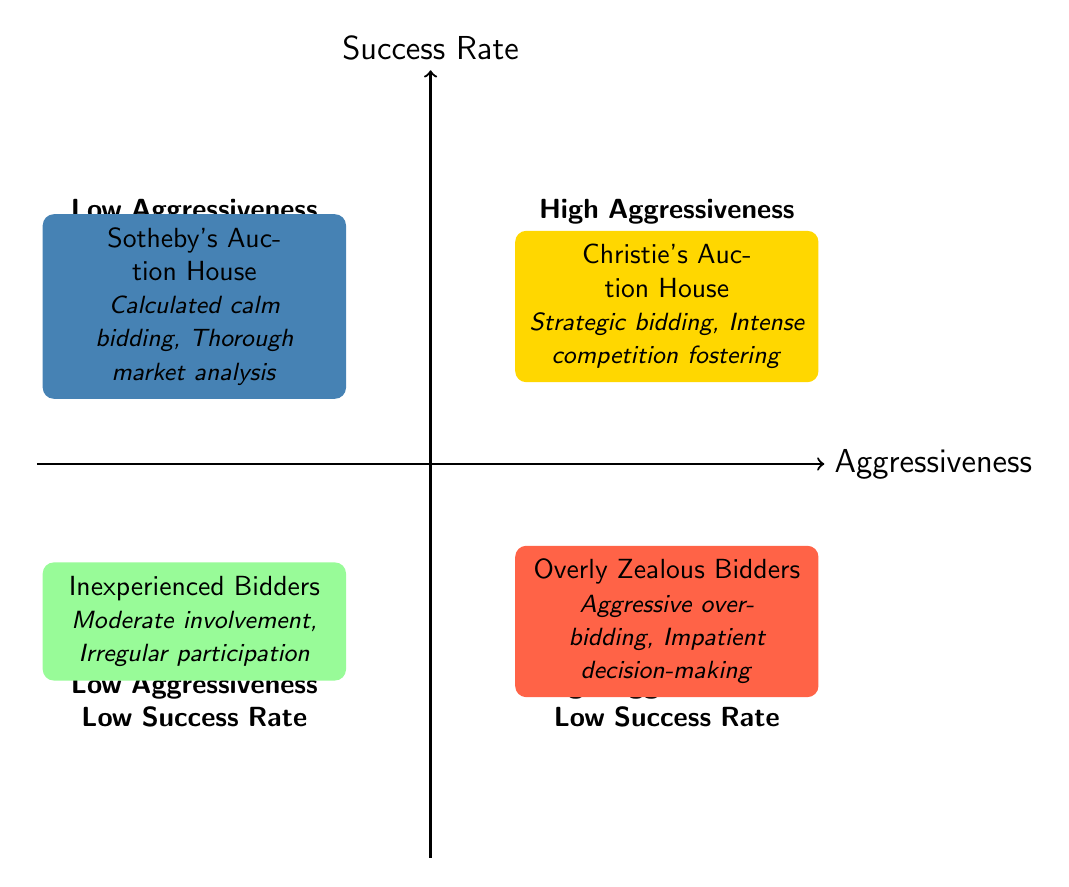What's in the top-right quadrant? The top-right quadrant is labeled "High Aggressiveness, High Success Rate", and contains the example "Christie's Auction House" along with its tactics.
Answer: Christie's Auction House Which tactic belongs to the bottom-left quadrant? The bottom-left quadrant is labeled "Low Aggressiveness, Low Success Rate", which provides the example "Inexperienced Bidders". Its tactics are "Moderate involvement" and "Irregular participation".
Answer: Moderate involvement How many quadrants are in the chart? The chart contains four quadrants, each representing different combinations of aggressiveness and success rate.
Answer: Four What example is in the high aggressiveness, low success rate category? The high aggressiveness, low success rate quadrant features "Overly Zealous Bidders".
Answer: Overly Zealous Bidders Which auction house focuses on calculated bidding? The low aggressiveness, high success rate quadrant includes "Sotheby's Auction House" known for its calculated bidding tactics.
Answer: Sotheby's Auction House List the tactics of Christie's Auction House. In the first quadrant labeled "High Aggressiveness, High Success Rate", the tactics listed for Christie's Auction House are "Strategic bidding" and "Intense competition fostering".
Answer: Strategic bidding, Intense competition fostering What is the primary characteristic of the low aggressiveness, high success rate quadrant? This quadrant emphasizes a calm approach to bidding, with detailed market analysis, represented by "Sotheby's Auction House".
Answer: Calculated calm bidding How do the high aggressiveness bidders generally perform? Based on the characteristics in the low success rate quadrant, high aggressiveness bidders tend to have a low success rate, demonstrating ineffective strategies.
Answer: Low success rate 